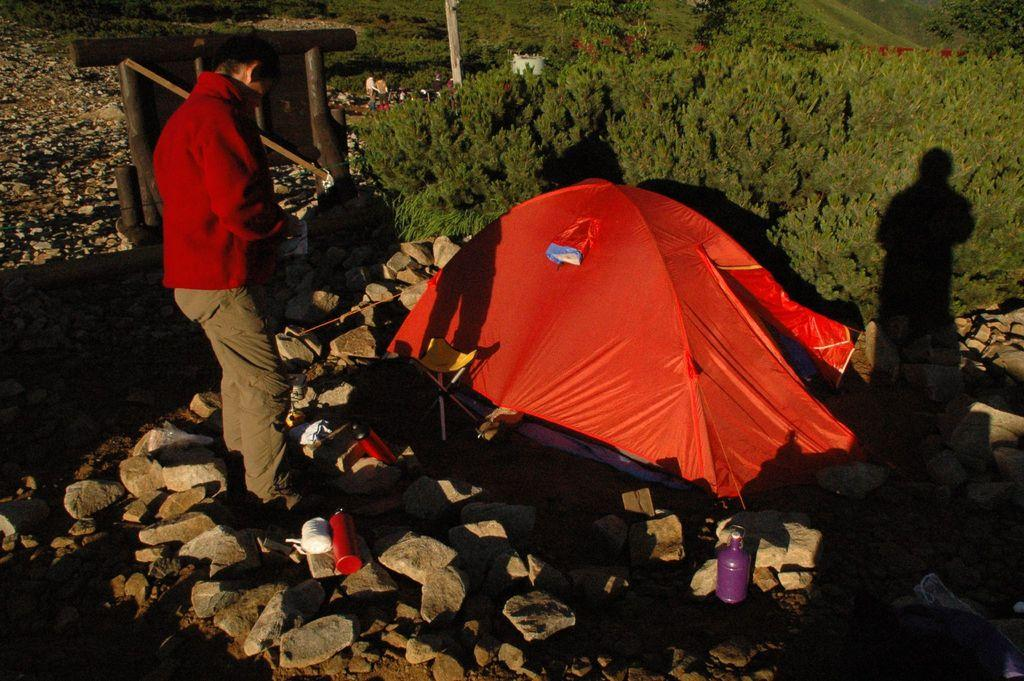What is the main subject of the image? There is a person standing in the image. What objects are on the ground in the image? There are bottles and rocks on the ground in the image. What type of shelter is present in the image? There is a tent in the image. What can be seen in the background of the image? There are trees in the background of the image. What type of cream is being used to play the guitar in the image? There is no cream or guitar present in the image. How much weight is the person lifting in the image? There is no indication of the person lifting any weight in the image. 